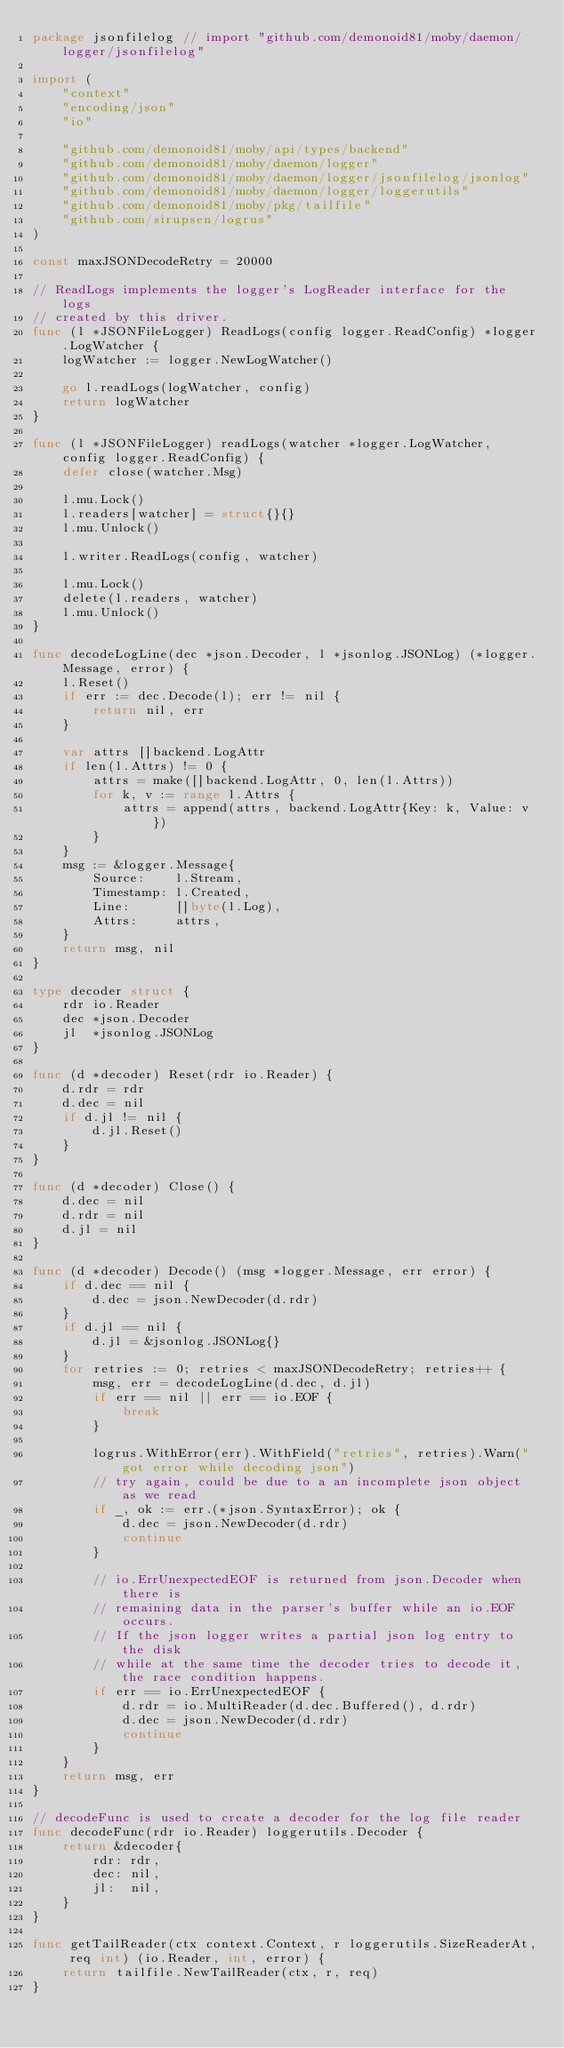Convert code to text. <code><loc_0><loc_0><loc_500><loc_500><_Go_>package jsonfilelog // import "github.com/demonoid81/moby/daemon/logger/jsonfilelog"

import (
	"context"
	"encoding/json"
	"io"

	"github.com/demonoid81/moby/api/types/backend"
	"github.com/demonoid81/moby/daemon/logger"
	"github.com/demonoid81/moby/daemon/logger/jsonfilelog/jsonlog"
	"github.com/demonoid81/moby/daemon/logger/loggerutils"
	"github.com/demonoid81/moby/pkg/tailfile"
	"github.com/sirupsen/logrus"
)

const maxJSONDecodeRetry = 20000

// ReadLogs implements the logger's LogReader interface for the logs
// created by this driver.
func (l *JSONFileLogger) ReadLogs(config logger.ReadConfig) *logger.LogWatcher {
	logWatcher := logger.NewLogWatcher()

	go l.readLogs(logWatcher, config)
	return logWatcher
}

func (l *JSONFileLogger) readLogs(watcher *logger.LogWatcher, config logger.ReadConfig) {
	defer close(watcher.Msg)

	l.mu.Lock()
	l.readers[watcher] = struct{}{}
	l.mu.Unlock()

	l.writer.ReadLogs(config, watcher)

	l.mu.Lock()
	delete(l.readers, watcher)
	l.mu.Unlock()
}

func decodeLogLine(dec *json.Decoder, l *jsonlog.JSONLog) (*logger.Message, error) {
	l.Reset()
	if err := dec.Decode(l); err != nil {
		return nil, err
	}

	var attrs []backend.LogAttr
	if len(l.Attrs) != 0 {
		attrs = make([]backend.LogAttr, 0, len(l.Attrs))
		for k, v := range l.Attrs {
			attrs = append(attrs, backend.LogAttr{Key: k, Value: v})
		}
	}
	msg := &logger.Message{
		Source:    l.Stream,
		Timestamp: l.Created,
		Line:      []byte(l.Log),
		Attrs:     attrs,
	}
	return msg, nil
}

type decoder struct {
	rdr io.Reader
	dec *json.Decoder
	jl  *jsonlog.JSONLog
}

func (d *decoder) Reset(rdr io.Reader) {
	d.rdr = rdr
	d.dec = nil
	if d.jl != nil {
		d.jl.Reset()
	}
}

func (d *decoder) Close() {
	d.dec = nil
	d.rdr = nil
	d.jl = nil
}

func (d *decoder) Decode() (msg *logger.Message, err error) {
	if d.dec == nil {
		d.dec = json.NewDecoder(d.rdr)
	}
	if d.jl == nil {
		d.jl = &jsonlog.JSONLog{}
	}
	for retries := 0; retries < maxJSONDecodeRetry; retries++ {
		msg, err = decodeLogLine(d.dec, d.jl)
		if err == nil || err == io.EOF {
			break
		}

		logrus.WithError(err).WithField("retries", retries).Warn("got error while decoding json")
		// try again, could be due to a an incomplete json object as we read
		if _, ok := err.(*json.SyntaxError); ok {
			d.dec = json.NewDecoder(d.rdr)
			continue
		}

		// io.ErrUnexpectedEOF is returned from json.Decoder when there is
		// remaining data in the parser's buffer while an io.EOF occurs.
		// If the json logger writes a partial json log entry to the disk
		// while at the same time the decoder tries to decode it, the race condition happens.
		if err == io.ErrUnexpectedEOF {
			d.rdr = io.MultiReader(d.dec.Buffered(), d.rdr)
			d.dec = json.NewDecoder(d.rdr)
			continue
		}
	}
	return msg, err
}

// decodeFunc is used to create a decoder for the log file reader
func decodeFunc(rdr io.Reader) loggerutils.Decoder {
	return &decoder{
		rdr: rdr,
		dec: nil,
		jl:  nil,
	}
}

func getTailReader(ctx context.Context, r loggerutils.SizeReaderAt, req int) (io.Reader, int, error) {
	return tailfile.NewTailReader(ctx, r, req)
}
</code> 